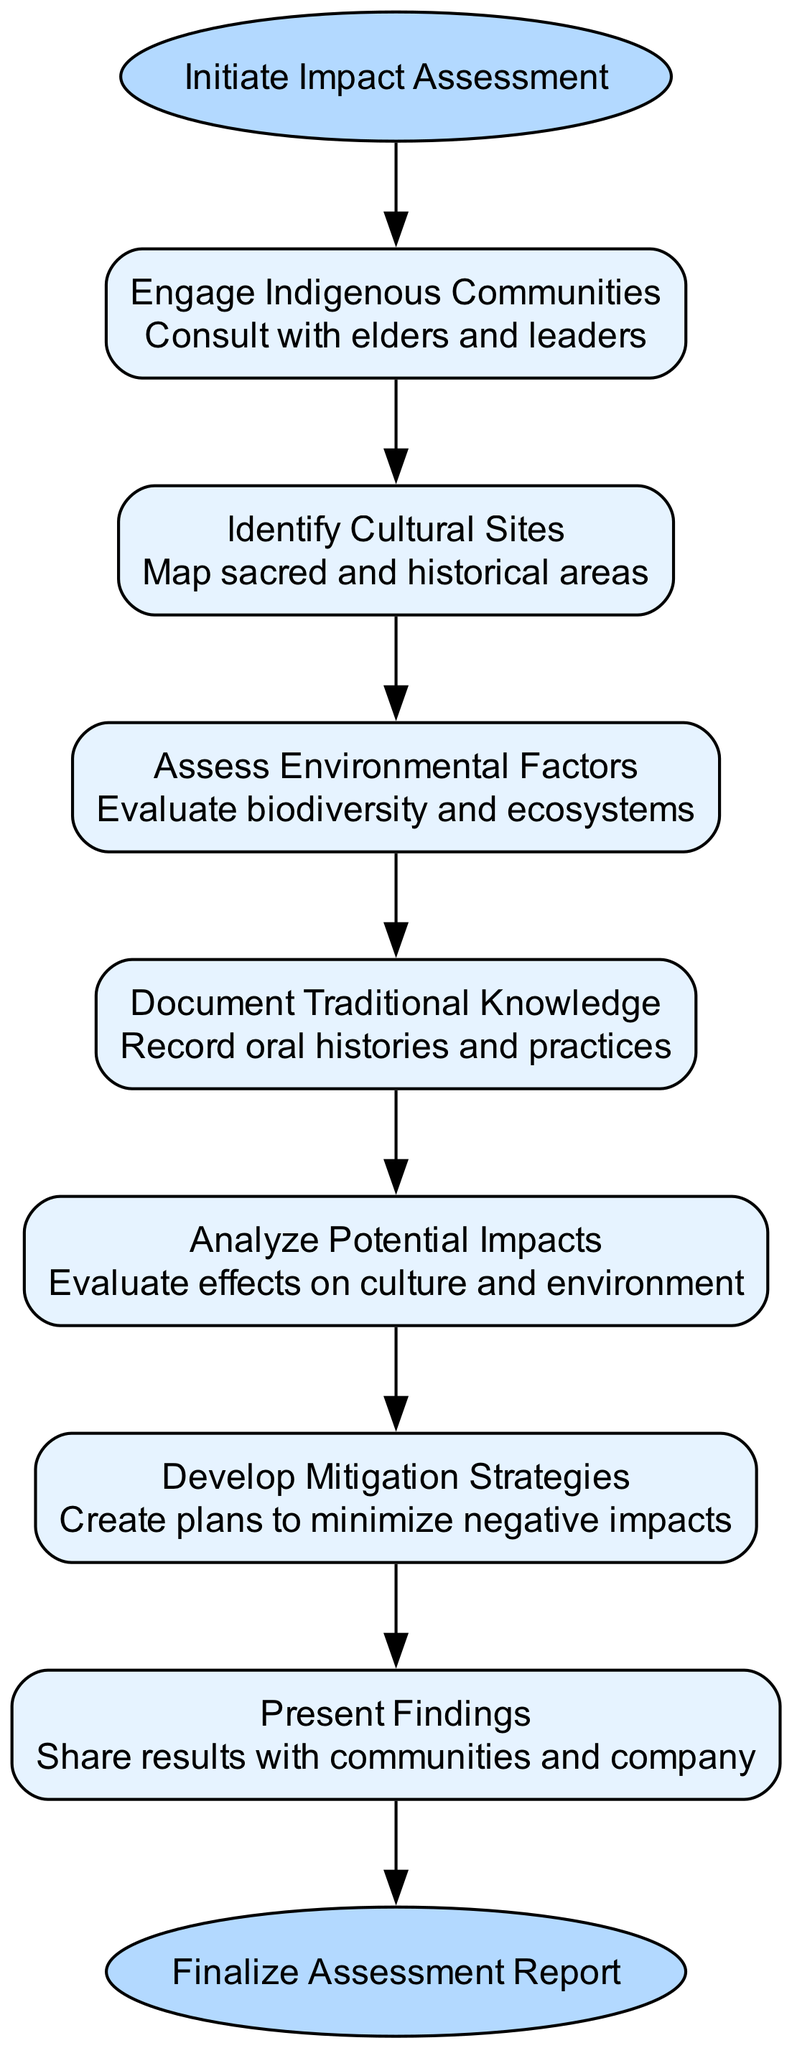What is the first step in the assessment process? The diagram clearly indicates that the first step is connected directly to the "start" node and labeled as "Engage Indigenous Communities". Thus, by following the flow from the starting point, we identify this as the initial action taken.
Answer: Engage Indigenous Communities How many total steps are there in the assessment process? To determine the total number of steps, we can count the nodes listed under the 'steps' section. There are six nodes for steps, plus the start and end nodes, totaling eight points in the diagram.
Answer: 6 Which step follows the "Document Traditional Knowledge"? The flow from the "Document Traditional Knowledge" step directs to the next node. By examining the sequence of steps in the diagram, it is clear that the following step is "Analyze Potential Impacts".
Answer: Analyze Potential Impacts What is the final step in the assessment process? At the end of the diagram, the node placed after all steps is labeled "Finalize Assessment Report", indicating it is the concluding action within this flow of the cultural and environmental impact assessments.
Answer: Finalize Assessment Report What is the purpose of the "Develop Mitigation Strategies" step? This step connects to the previous steps and is designed to create plans that minimize the negative impacts evaluated in the earlier stage. Understanding this step in relation to preceding assessments highlights its role in addressing potential issues identified.
Answer: Create plans to minimize negative impacts What types of communities are engaged at the start of the process? The first step "Engage Indigenous Communities" specifically indicates that this is the focus at the beginning of the assessment, emphasizing the involvement of traditional holders of knowledge and rights in the cultural context.
Answer: Indigenous Communities 